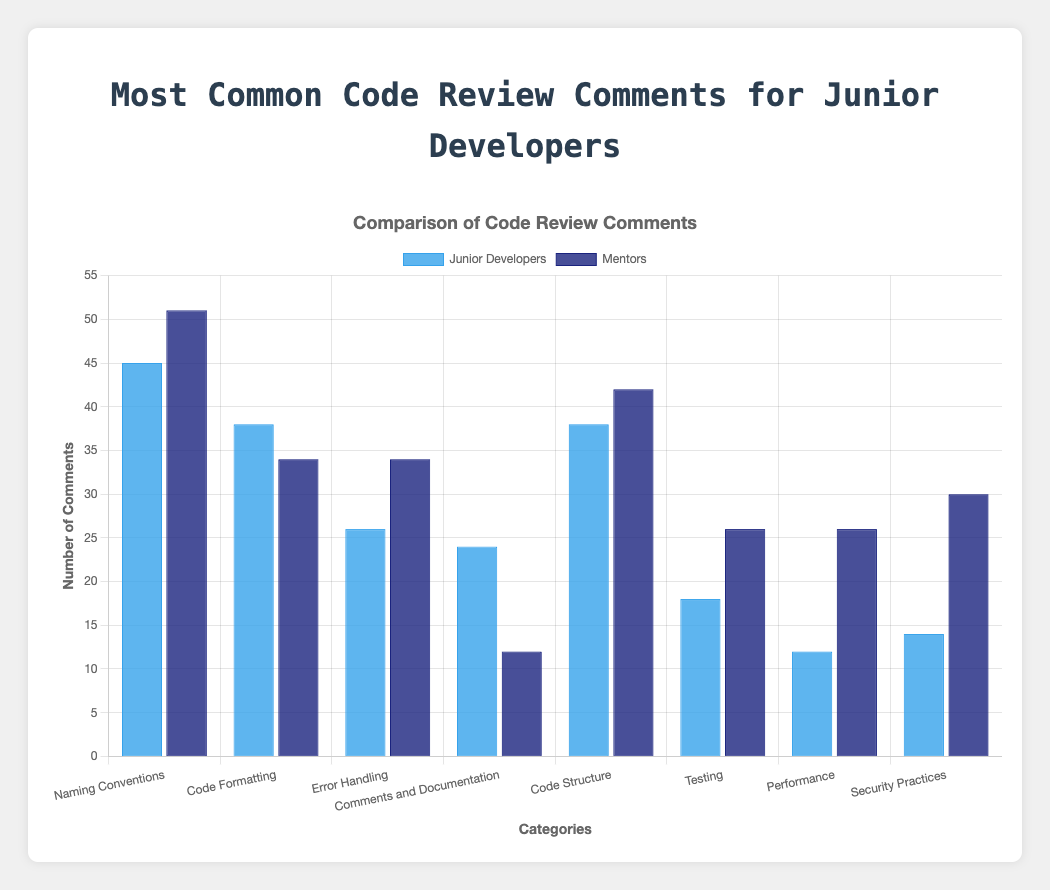Which category has the most comments from junior developers? Look at the heights of the blue bars. The "Naming Conventions" category has the tallest blue bar.
Answer: Naming Conventions Which category has the most comments from mentors? Look at the heights of the dark blue bars. The "Naming Conventions" category has the tallest dark blue bar.
Answer: Naming Conventions Compare the total number of comments in "Testing" for junior developers and mentors. Which group has more? Sum the values for "Testing" among junior developers (3+5+6+4 = 18) and mentors (5+6+7+8 = 26). Mentors have more comments.
Answer: Mentors How does the number of comments for "Error Handling" differ between junior developers and mentors? Sum the "Error Handling" values for junior developers (7+8+6+5 = 26) and mentors (9+10+8+7 = 34). Subtract the totals (34-26 = 8).
Answer: 8 more for mentors In which category do junior developers receive the least comments? The shortest blue bar corresponds to "Security Practices" with a total of (2+4+3+5 = 14).
Answer: Security Practices What's the average number of comments in the "Code Structure" category from both groups combined? Sum the "Code Structure" values for both groups (10+8+9+11+11+12+10+9 = 80). There are 8 entries. Average is 80/8 = 10.
Answer: 10 In which category do junior developers perform relatively better, receiving fewer comments than mentors? Identify categories where the blue bar is shorter than the dark blue bar: "Comments and Documentation", "Error Handling", "Testing", "Performance", and "Security Practices".
Answer: Comments and Documentation, Error Handling, Testing, Performance, Security Practices How many total comments did the mentors make on "Code Formatting"? Sum all values in "Code Formatting" for mentors (8+7+9+10 = 34).
Answer: 34 